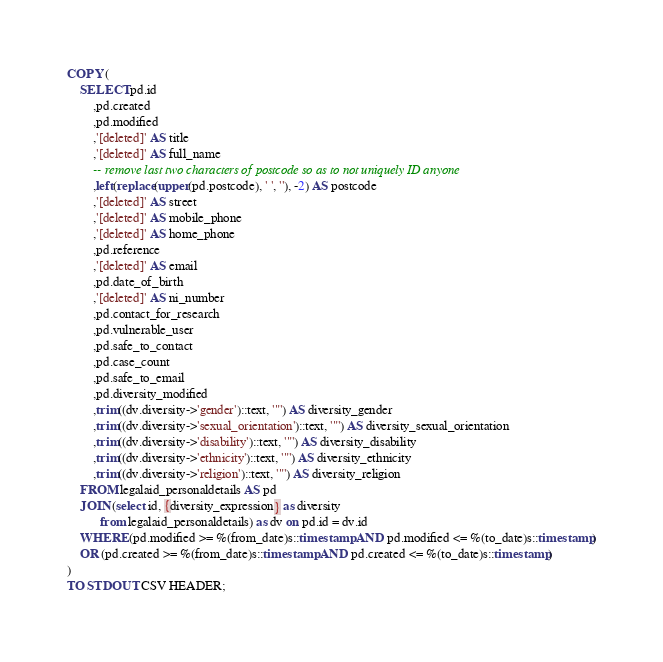<code> <loc_0><loc_0><loc_500><loc_500><_SQL_>COPY (
    SELECT pd.id
        ,pd.created
        ,pd.modified
        ,'[deleted]' AS title
        ,'[deleted]' AS full_name
        -- remove last two characters of postcode so as to not uniquely ID anyone
        ,left(replace(upper(pd.postcode), ' ', ''), -2) AS postcode
        ,'[deleted]' AS street
        ,'[deleted]' AS mobile_phone
        ,'[deleted]' AS home_phone
        ,pd.reference
        ,'[deleted]' AS email
        ,pd.date_of_birth
        ,'[deleted]' AS ni_number
        ,pd.contact_for_research
        ,pd.vulnerable_user
        ,pd.safe_to_contact
        ,pd.case_count
        ,pd.safe_to_email
        ,pd.diversity_modified
        ,trim((dv.diversity->'gender')::text, '"') AS diversity_gender
        ,trim((dv.diversity->'sexual_orientation')::text, '"') AS diversity_sexual_orientation
        ,trim((dv.diversity->'disability')::text, '"') AS diversity_disability
        ,trim((dv.diversity->'ethnicity')::text, '"') AS diversity_ethnicity
        ,trim((dv.diversity->'religion')::text, '"') AS diversity_religion
    FROM legalaid_personaldetails AS pd
    JOIN (select id, {diversity_expression} as diversity
          from legalaid_personaldetails) as dv on pd.id = dv.id
    WHERE (pd.modified >= %(from_date)s::timestamp AND pd.modified <= %(to_date)s::timestamp)
    OR (pd.created >= %(from_date)s::timestamp AND pd.created <= %(to_date)s::timestamp)
)
TO STDOUT CSV HEADER;
</code> 